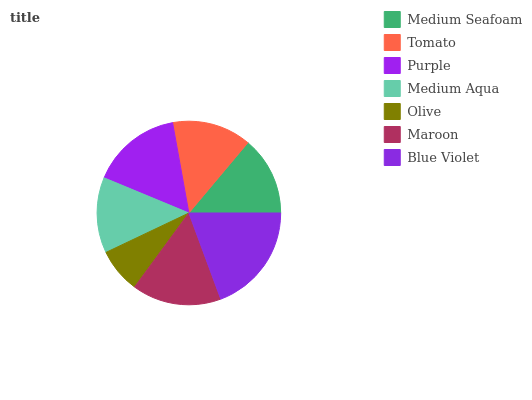Is Olive the minimum?
Answer yes or no. Yes. Is Blue Violet the maximum?
Answer yes or no. Yes. Is Tomato the minimum?
Answer yes or no. No. Is Tomato the maximum?
Answer yes or no. No. Is Tomato greater than Medium Seafoam?
Answer yes or no. Yes. Is Medium Seafoam less than Tomato?
Answer yes or no. Yes. Is Medium Seafoam greater than Tomato?
Answer yes or no. No. Is Tomato less than Medium Seafoam?
Answer yes or no. No. Is Tomato the high median?
Answer yes or no. Yes. Is Tomato the low median?
Answer yes or no. Yes. Is Medium Aqua the high median?
Answer yes or no. No. Is Medium Aqua the low median?
Answer yes or no. No. 